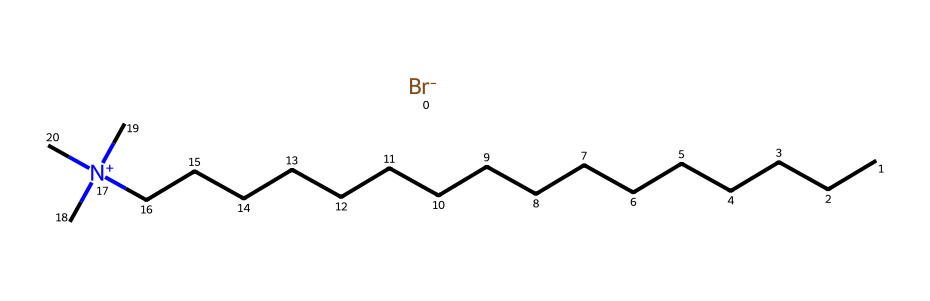What is the total number of carbon atoms in this molecule? In the provided SMILES representation, the carbon chain is denoted by the series of 'C's. Counting these, we find there are 16 carbon atoms present in the straight chain, plus three additional carbon atoms connected to the nitrogen. Thus, the total is 16 + 3 = 19.
Answer: 19 How many nitrogen atoms are in this compound? The SMILES representation includes a '[N+]' notation, indicating the presence of one nitrogen atom. Therefore, there is a single nitrogen atom in this molecule.
Answer: 1 What functional group is indicated by the presence of the '[Br-]' in the structure? The notation '[Br-]' signifies that there is a bromine atom with a negative charge, which indicates that this chemical is a quaternary ammonium salt. This functional group is often involved in ionic interactions.
Answer: quaternary ammonium salt What charge does the nitrogen in cetrimonium bromide carry? The '[N+]' notation indicates the nitrogen atom carries a positive charge due to the three surrounding carbon atoms and the lack of an additional non-bonded electron pair. Hence, it is positively charged.
Answer: positive Is this molecule hydrophobic or hydrophilic overall? The long carbon chain contributes to hydrophobic characteristics while the quaternary ammonium structure makes it hydrophilic, giving it amphiphilic properties. The overall features suggest it's a surfactant with both properties.
Answer: amphiphilic How does the length of the carbon chain influence the properties of this compound? The long carbon chain imparts hydrophobic characteristics that enhance its ability as a surfactant, while also affecting solubility and viscosity in formulations, thereby influencing its effectiveness in fabric softeners and conditioners.
Answer: hydrophobic properties 